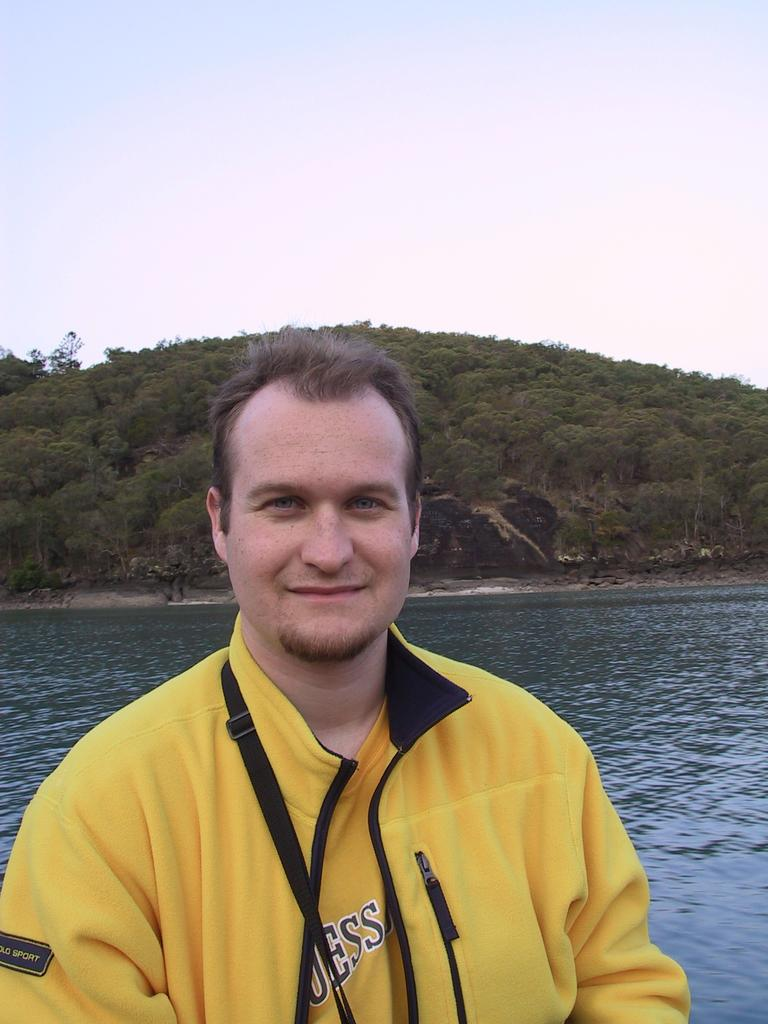<image>
Share a concise interpretation of the image provided. A man wearing a yellow Guess shirt is posing for the picture in front of a body of water. 